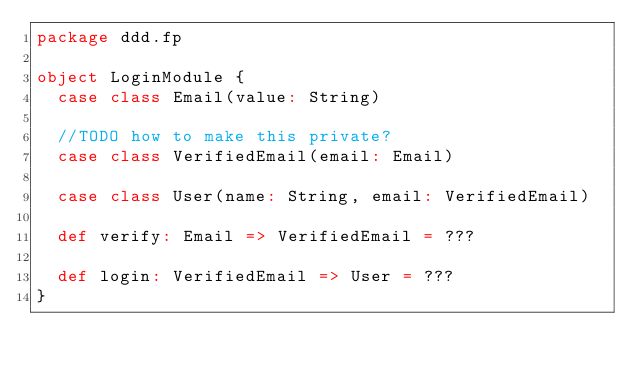<code> <loc_0><loc_0><loc_500><loc_500><_Scala_>package ddd.fp

object LoginModule {
  case class Email(value: String)

  //TODO how to make this private?
  case class VerifiedEmail(email: Email)

  case class User(name: String, email: VerifiedEmail)

  def verify: Email => VerifiedEmail = ???

  def login: VerifiedEmail => User = ???
}
</code> 